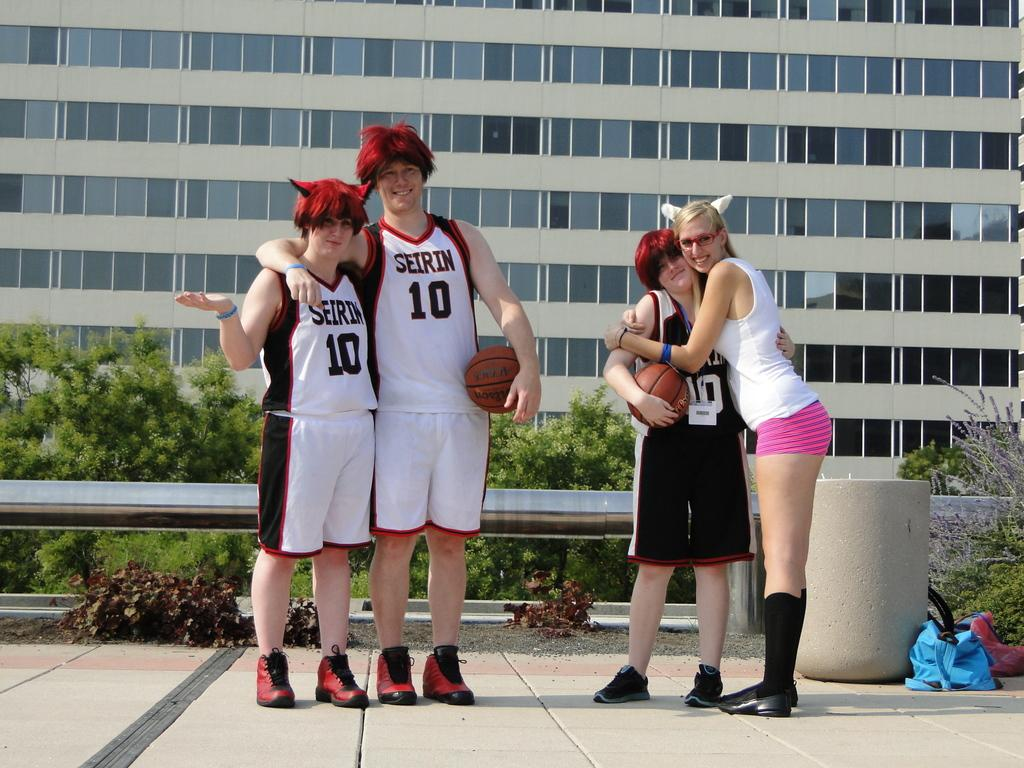<image>
Provide a brief description of the given image. Three people wearing Seirin basketball jerseys and the number 10 pose for a photo. 